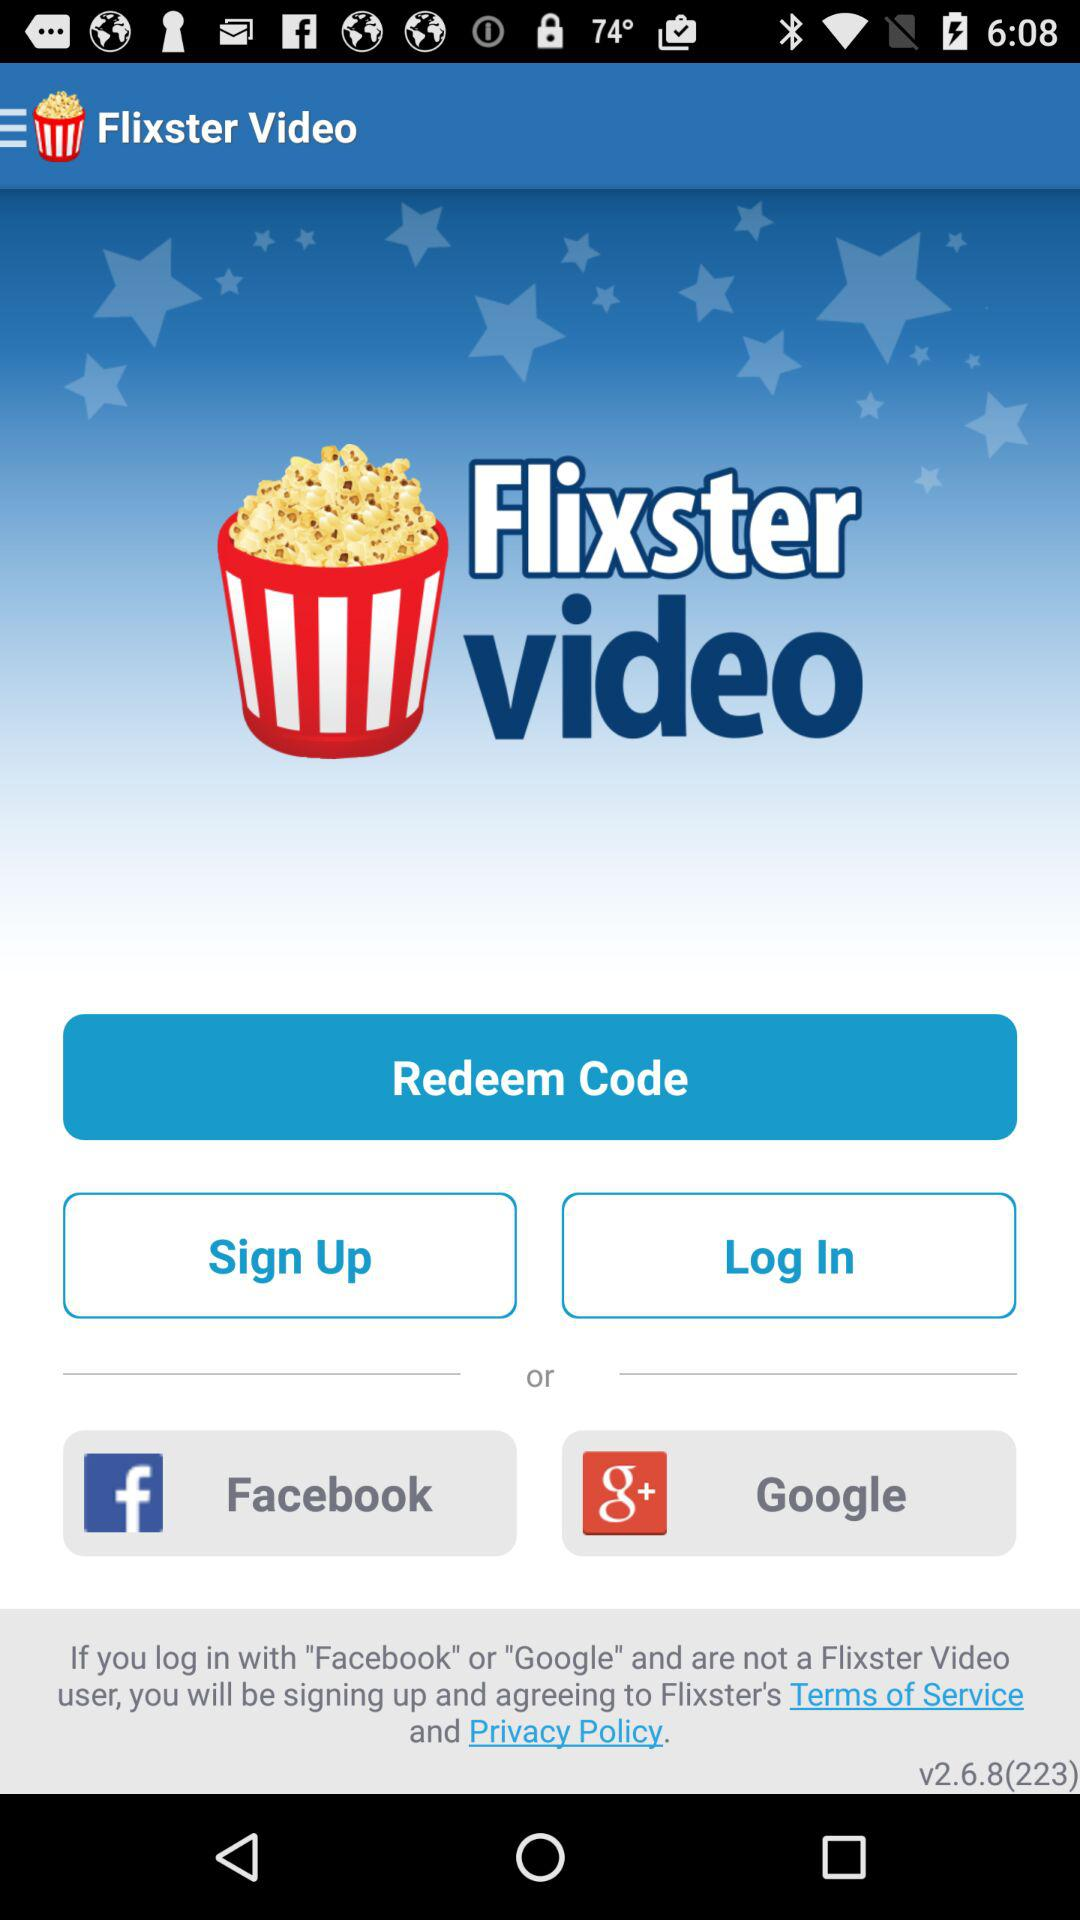What is the name of the application? The name of the application is "Flixster Video". 